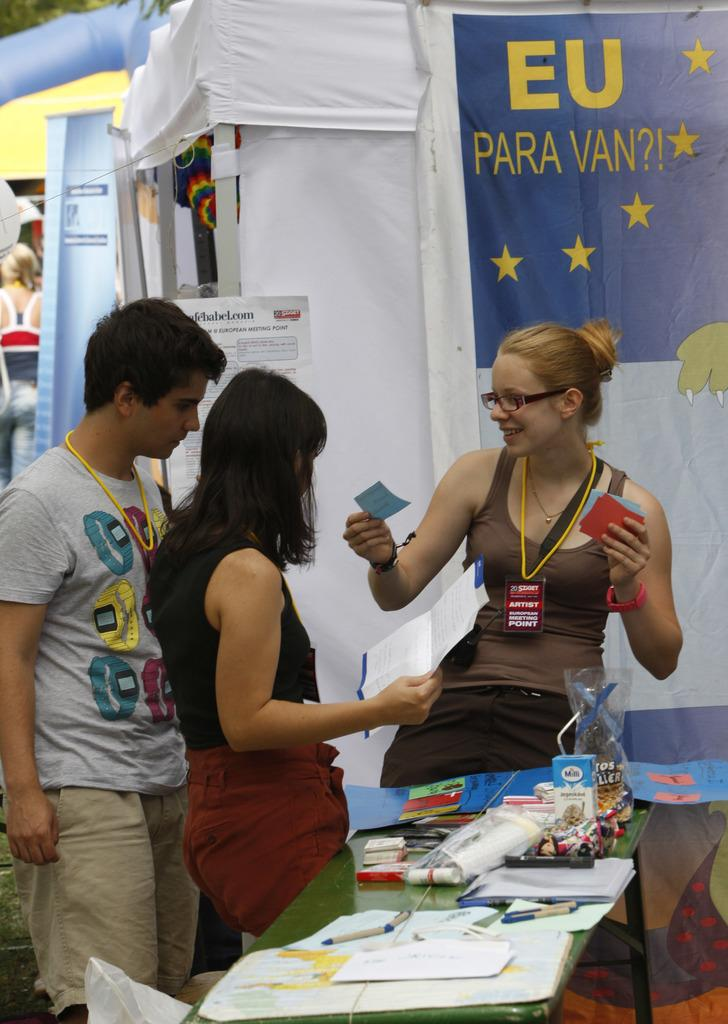<image>
Render a clear and concise summary of the photo. A group of students hanging out by a EU para van sign 